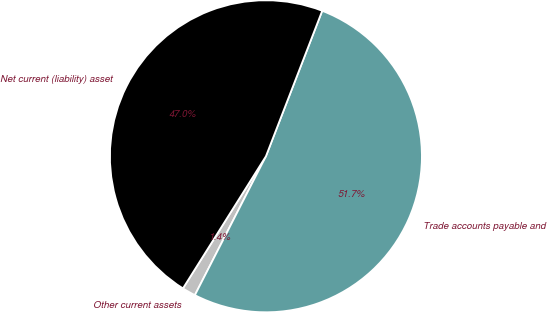Convert chart. <chart><loc_0><loc_0><loc_500><loc_500><pie_chart><fcel>Other current assets<fcel>Trade accounts payable and<fcel>Net current (liability) asset<nl><fcel>1.4%<fcel>51.65%<fcel>46.95%<nl></chart> 